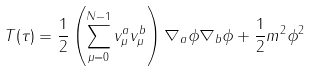Convert formula to latex. <formula><loc_0><loc_0><loc_500><loc_500>T ( \tau ) = \frac { 1 } { 2 } \left ( \sum _ { \mu = 0 } ^ { N - 1 } v _ { \mu } ^ { a } v _ { \mu } ^ { b } \right ) \nabla _ { a } \phi \nabla _ { b } \phi + \frac { 1 } { 2 } m ^ { 2 } \phi ^ { 2 }</formula> 